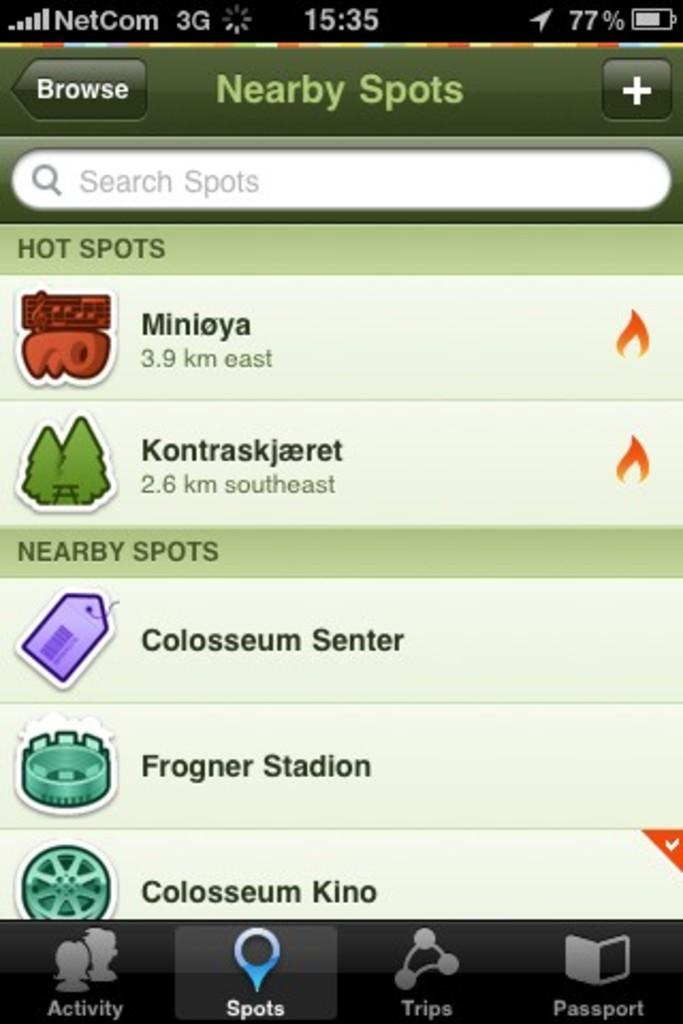<image>
Give a short and clear explanation of the subsequent image. A screen from a phone that has Colosseum Senter as a nearby spot 